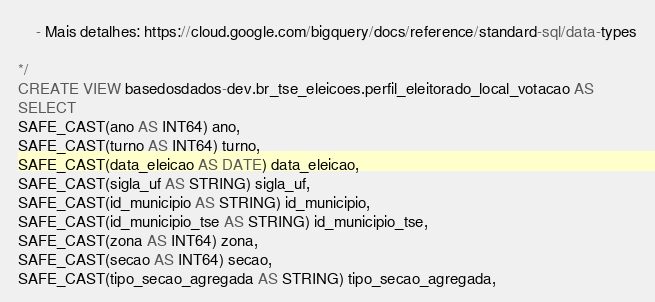<code> <loc_0><loc_0><loc_500><loc_500><_SQL_>    - Mais detalhes: https://cloud.google.com/bigquery/docs/reference/standard-sql/data-types

*/
CREATE VIEW basedosdados-dev.br_tse_eleicoes.perfil_eleitorado_local_votacao AS
SELECT 
SAFE_CAST(ano AS INT64) ano,
SAFE_CAST(turno AS INT64) turno,
SAFE_CAST(data_eleicao AS DATE) data_eleicao,
SAFE_CAST(sigla_uf AS STRING) sigla_uf,
SAFE_CAST(id_municipio AS STRING) id_municipio,
SAFE_CAST(id_municipio_tse AS STRING) id_municipio_tse,
SAFE_CAST(zona AS INT64) zona,
SAFE_CAST(secao AS INT64) secao,
SAFE_CAST(tipo_secao_agregada AS STRING) tipo_secao_agregada,</code> 